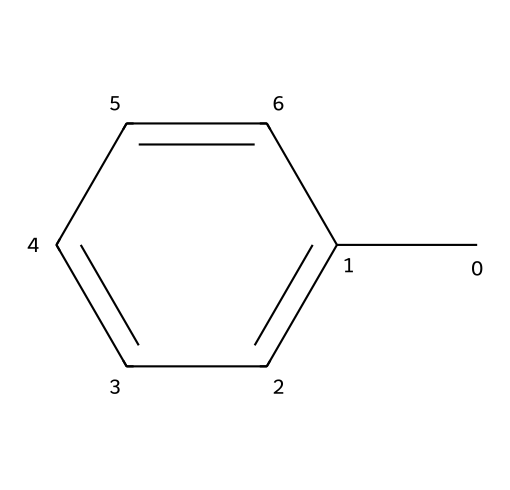What is the molecular formula of this compound? The structure given corresponds to toluene, which consists of 7 carbon atoms and 8 hydrogen atoms. The molecular formula can be derived directly by counting the number of each type of atom present, which is C7H8.
Answer: C7H8 How many hydrogen atoms are present in toluene? By analyzing the SMILES representation, one can observe that there are 8 hydrogen atoms connected to the carbon framework. Each carbon typically bonds with enough hydrogen to fulfill its tetravalency.
Answer: 8 What type of solvent is toluene? Toluene is an aromatic hydrocarbon, derived from its feature of a benzene ring with a methyl group (-CH3) attached. Its aromaticity distinguishes it within solvent types, indicating it is capable of dissolving many organic compounds.
Answer: aromatic Which part of the molecule indicates its function as a solvent? The presence of the benzene ring structure, which is characteristic of aromatic hydrocarbons like toluene, indicates its effectiveness as a solvent for various organic materials due to its non-polar nature.
Answer: benzene ring What kind of interactions does toluene primarily utilize for solvation? Toluene, being a non-polar solvent, primarily participates in dispersion forces (London forces) during solvation, which allows it to dissolve other non-polar substances effectively.
Answer: dispersion forces How does the structure of toluene affect its volatility? The simple, symmetrical structure of toluene allows for relatively weak intermolecular forces leading to a higher volatility compared to larger, more complex hydrocarbons. This is due to its low molecular weight and aromatic nature.
Answer: high volatility 